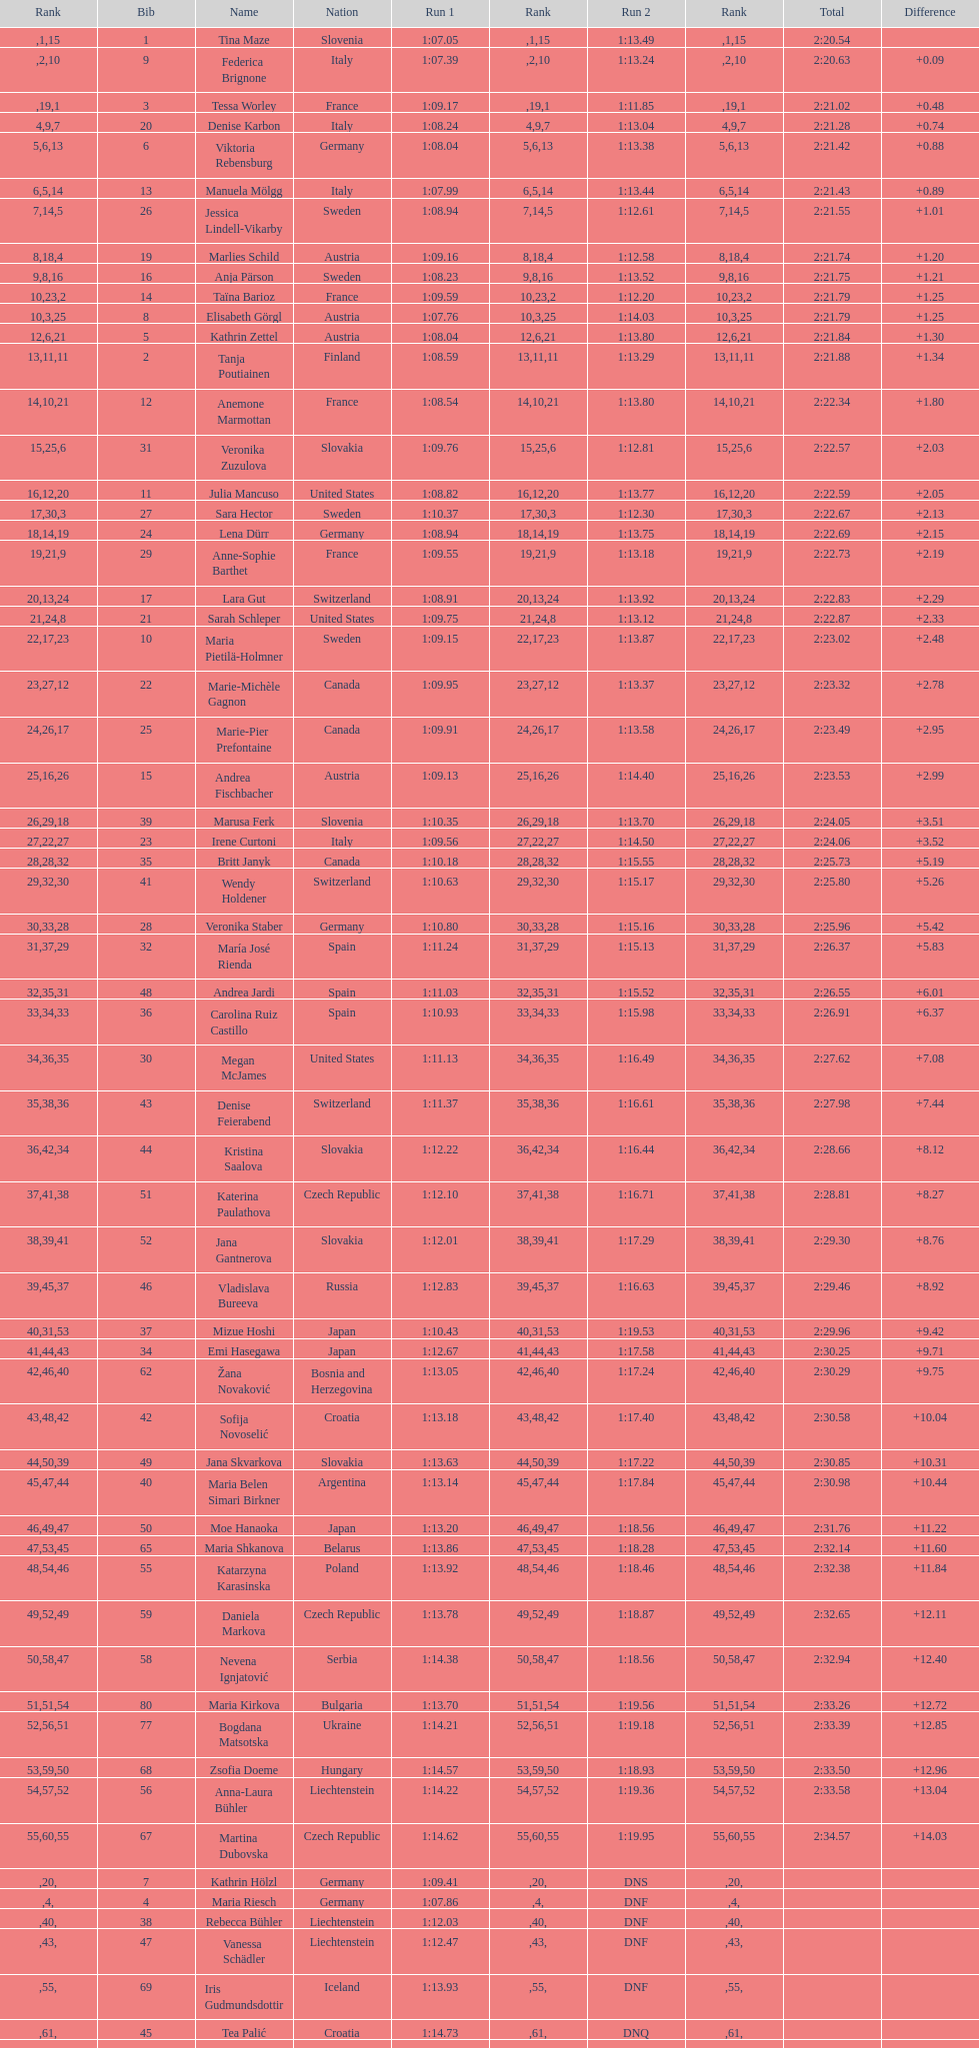What was the number of swedes in the top fifteen? 2. 